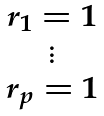<formula> <loc_0><loc_0><loc_500><loc_500>\begin{matrix} r _ { 1 } = 1 \\ \vdots \\ r _ { p } = 1 \end{matrix}</formula> 